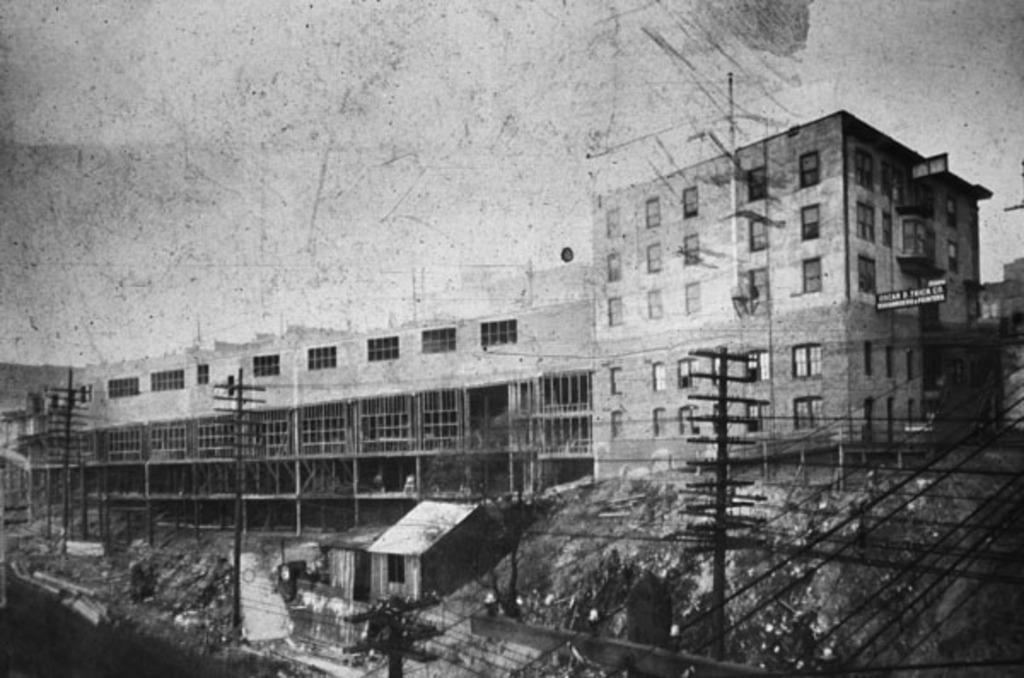What is the color scheme of the image? The image is black and white. What type of structures can be seen in the image? There are buildings, a house, and a shed in the image. What other objects are present in the image? There are poles, a board, and other objects in the image. What can be seen in the background of the image? The sky is visible in the background of the image. Where is the desk located in the image? There is no desk present in the image. What type of addition is being made to the house in the image? There is no addition being made to the house in the image. How many cattle can be seen grazing in the image? There are no cattle present in the image. 